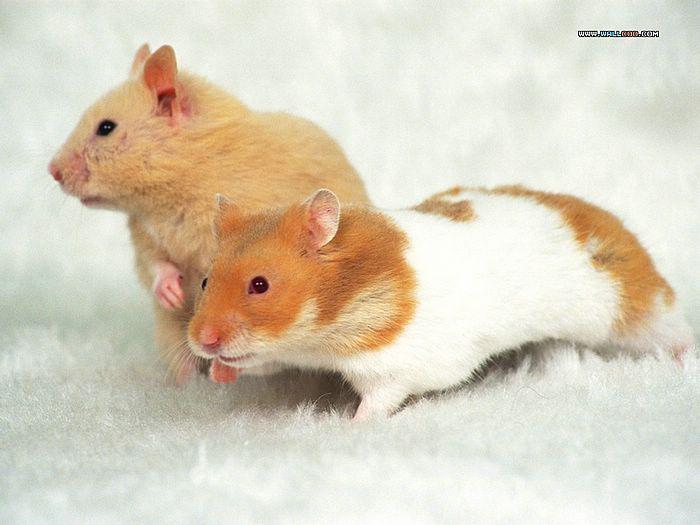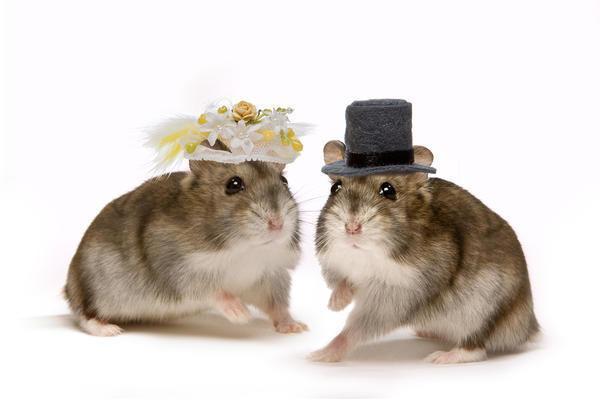The first image is the image on the left, the second image is the image on the right. Evaluate the accuracy of this statement regarding the images: "None of these rodents is snacking on a carrot slice.". Is it true? Answer yes or no. Yes. The first image is the image on the left, the second image is the image on the right. Evaluate the accuracy of this statement regarding the images: "At least one hamster is eating a piece of carrot.". Is it true? Answer yes or no. No. 